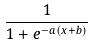<formula> <loc_0><loc_0><loc_500><loc_500>\frac { 1 } { 1 + e ^ { - a ( x + b ) } }</formula> 